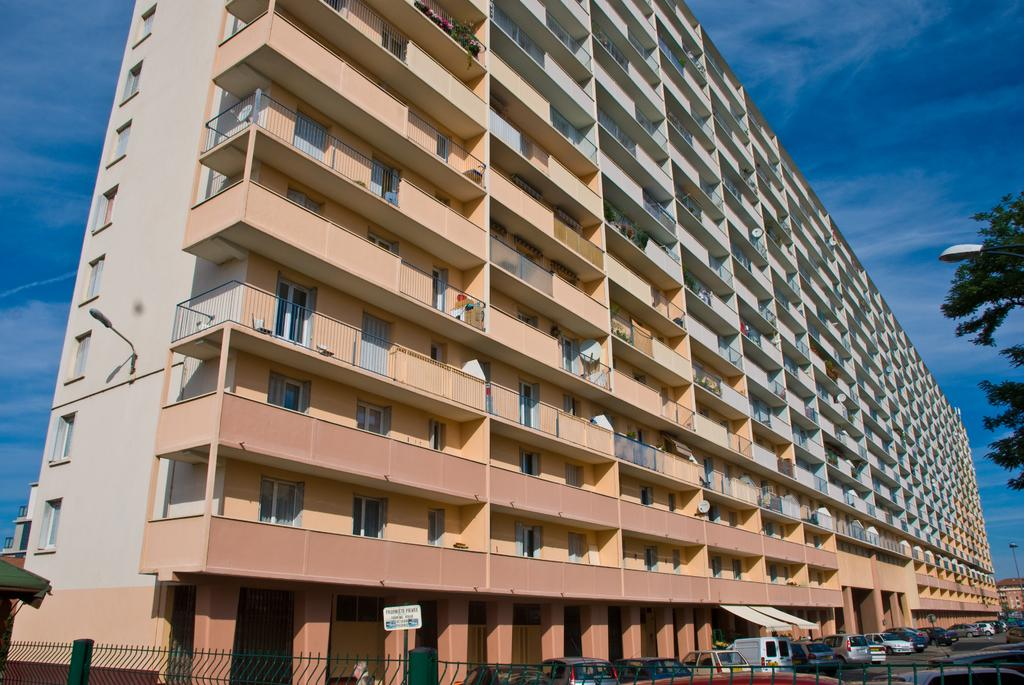What type of structures can be seen in the image? There are buildings in the image. What are the light poles used for in the image? The light poles provide illumination in the image. What is in front of the buildings? There are vehicles, a fence, a tree, and a board in front of the buildings. What is visible in the background of the image? The sky is visible in the image. Can you see a pear growing on the tree in the image? There is no pear visible on the tree in the image. Is there a lake in the background of the image? There is no lake present in the image. 